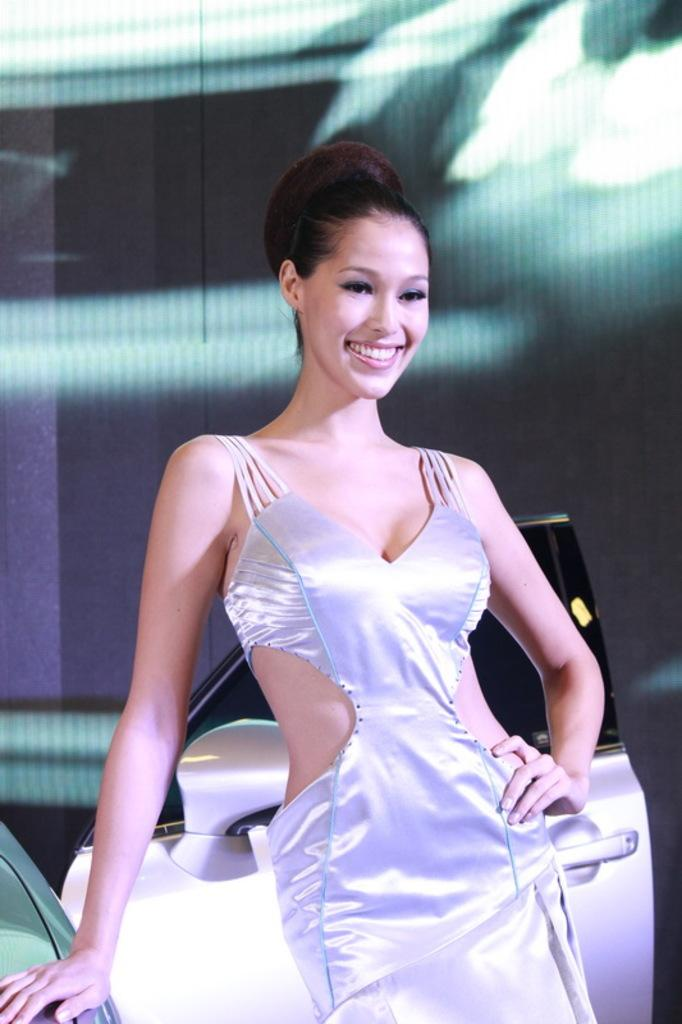Who is the main subject in the image? There is a woman in the center of the image. What is located behind the woman? There is a car behind the woman. What type of bun is the woman holding in the image? There is no bun present in the image. How many pages can be seen in the image? There are no pages visible in the image. 